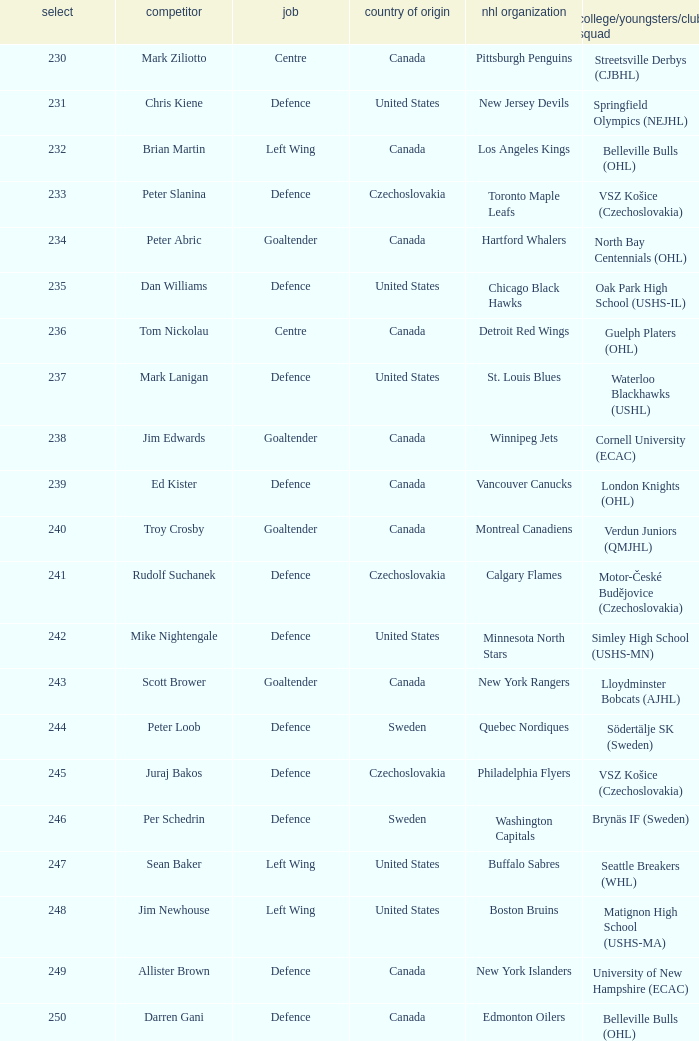Could you parse the entire table? {'header': ['select', 'competitor', 'job', 'country of origin', 'nhl organization', 'college/youngsters/club squad'], 'rows': [['230', 'Mark Ziliotto', 'Centre', 'Canada', 'Pittsburgh Penguins', 'Streetsville Derbys (CJBHL)'], ['231', 'Chris Kiene', 'Defence', 'United States', 'New Jersey Devils', 'Springfield Olympics (NEJHL)'], ['232', 'Brian Martin', 'Left Wing', 'Canada', 'Los Angeles Kings', 'Belleville Bulls (OHL)'], ['233', 'Peter Slanina', 'Defence', 'Czechoslovakia', 'Toronto Maple Leafs', 'VSZ Košice (Czechoslovakia)'], ['234', 'Peter Abric', 'Goaltender', 'Canada', 'Hartford Whalers', 'North Bay Centennials (OHL)'], ['235', 'Dan Williams', 'Defence', 'United States', 'Chicago Black Hawks', 'Oak Park High School (USHS-IL)'], ['236', 'Tom Nickolau', 'Centre', 'Canada', 'Detroit Red Wings', 'Guelph Platers (OHL)'], ['237', 'Mark Lanigan', 'Defence', 'United States', 'St. Louis Blues', 'Waterloo Blackhawks (USHL)'], ['238', 'Jim Edwards', 'Goaltender', 'Canada', 'Winnipeg Jets', 'Cornell University (ECAC)'], ['239', 'Ed Kister', 'Defence', 'Canada', 'Vancouver Canucks', 'London Knights (OHL)'], ['240', 'Troy Crosby', 'Goaltender', 'Canada', 'Montreal Canadiens', 'Verdun Juniors (QMJHL)'], ['241', 'Rudolf Suchanek', 'Defence', 'Czechoslovakia', 'Calgary Flames', 'Motor-České Budějovice (Czechoslovakia)'], ['242', 'Mike Nightengale', 'Defence', 'United States', 'Minnesota North Stars', 'Simley High School (USHS-MN)'], ['243', 'Scott Brower', 'Goaltender', 'Canada', 'New York Rangers', 'Lloydminster Bobcats (AJHL)'], ['244', 'Peter Loob', 'Defence', 'Sweden', 'Quebec Nordiques', 'Södertälje SK (Sweden)'], ['245', 'Juraj Bakos', 'Defence', 'Czechoslovakia', 'Philadelphia Flyers', 'VSZ Košice (Czechoslovakia)'], ['246', 'Per Schedrin', 'Defence', 'Sweden', 'Washington Capitals', 'Brynäs IF (Sweden)'], ['247', 'Sean Baker', 'Left Wing', 'United States', 'Buffalo Sabres', 'Seattle Breakers (WHL)'], ['248', 'Jim Newhouse', 'Left Wing', 'United States', 'Boston Bruins', 'Matignon High School (USHS-MA)'], ['249', 'Allister Brown', 'Defence', 'Canada', 'New York Islanders', 'University of New Hampshire (ECAC)'], ['250', 'Darren Gani', 'Defence', 'Canada', 'Edmonton Oilers', 'Belleville Bulls (OHL)']]} Which draft number did the new jersey devils get? 231.0. 